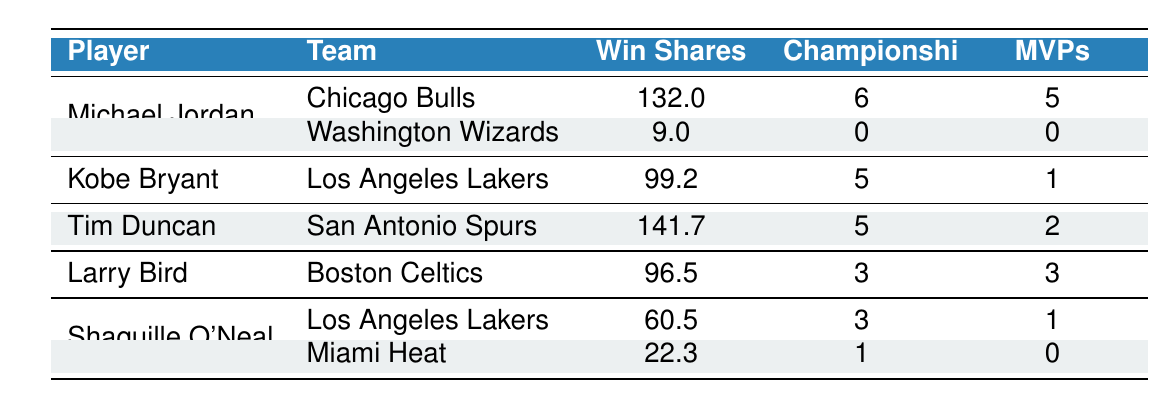What is the total number of Championships won by Michael Jordan? Michael Jordan won 6 Championships with the Chicago Bulls, and 0 Championships with the Washington Wizards. Therefore, the total is 6 + 0 = 6.
Answer: 6 Which player has the highest Win Shares and what is that value? Tim Duncan has the highest Win Shares at 141.7 while playing for the San Antonio Spurs.
Answer: 141.7 Did Shaquille O'Neal win more Championships with the Los Angeles Lakers or the Miami Heat? Shaquille O'Neal won 3 Championships with the Los Angeles Lakers and 1 Championship with the Miami Heat. Therefore, he won more Championships with the Lakers (3 > 1).
Answer: Yes What is the average number of MVPs among all players listed? The players have the following MVPs: Michael Jordan (5), Kobe Bryant (1), Tim Duncan (2), Larry Bird (3), and Shaquille O'Neal (1). Adding these gives us a total of 12 MVPs, and since there are 5 players, the average is 12/5 = 2.4.
Answer: 2.4 How many total Championships do all players listed have combined? The total Championships are: Michael Jordan (6) + Kobe Bryant (5) + Tim Duncan (5) + Larry Bird (3) + Shaquille O'Neal (4). Summing these gives 6 + 5 + 5 + 3 + 4 = 23.
Answer: 23 Is it true that Larry Bird has more Win Shares than Shaquille O'Neal? Larry Bird has 96.5 Win Shares, while Shaquille O'Neal has a combined total of 82.8 (60.5 with the Lakers and 22.3 with the Heat). Thus, 96.5 is greater than 82.8, making the statement true.
Answer: Yes What is the sum of Win Shares for all players who played for the Los Angeles Lakers? The Win Shares for players who played for the Lakers are: Kobe Bryant (99.2) and Shaquille O'Neal (60.5). The sum is 99.2 + 60.5 = 159.7.
Answer: 159.7 What is the difference in total Championship wins between Michael Jordan and Tim Duncan? Michael Jordan won 6 Championships and Tim Duncan won 5 Championships. The difference is 6 - 5 = 1.
Answer: 1 Which player has the least total Win Shares and what is that value? Michael Jordan has the second-fewest Win Shares with 9 from the Washington Wizards. The player with fewer total Win Shares is Shaquille O'Neal's 22.3 with the Miami Heat, but considering his Lakers total, Jordan's 9 is less than both, making it clear Jordan has the least at that team level.
Answer: 9 